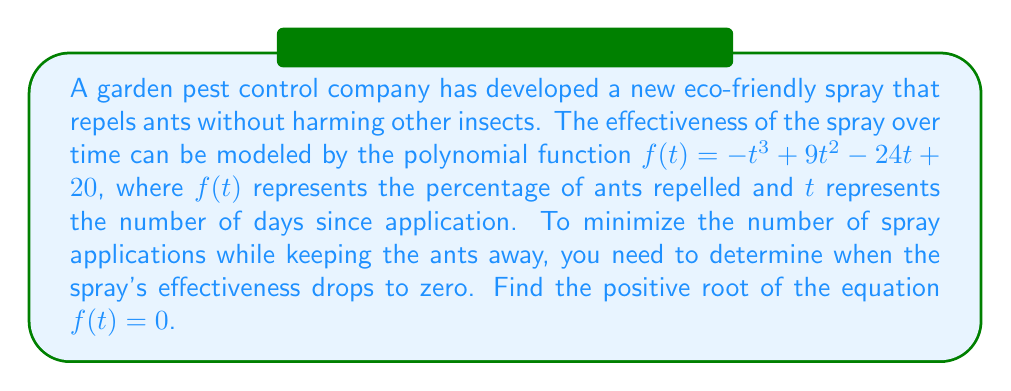Give your solution to this math problem. Let's solve this step-by-step:

1) We need to solve the equation $f(t) = 0$:
   $-t^3 + 9t^2 - 24t + 20 = 0$

2) This is a cubic equation. One way to solve it is by factoring.

3) Let's try to guess one factor. We can see that when $t = 2$, 
   $f(2) = -8 + 36 - 48 + 20 = 0$

4) So, $(t - 2)$ is a factor. We can factor it out:
   $-(t - 2)(t^2 + 7t - 10) = 0$

5) Now we can factor the quadratic term:
   $-(t - 2)(t + 10)(t - 3) = 0$

6) The roots of this equation are $t = 2$, $t = -10$, and $t = 3$

7) We're only interested in positive roots, so we can discard $-10$

8) Between 2 and 3, we choose the larger value as we want to maximize the time between applications

Therefore, the spray's effectiveness drops to zero after 3 days.
Answer: 3 days 